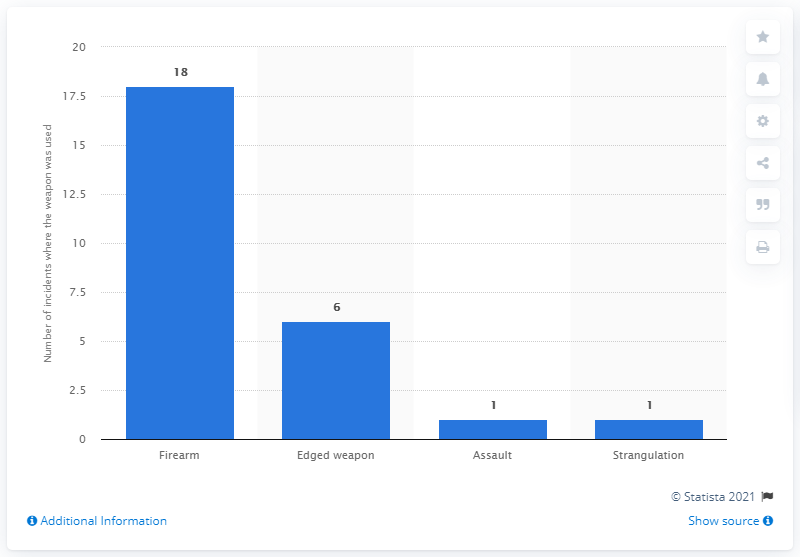Specify some key components in this picture. In the period between 2000 and 2016, firearms were used in 18 hate crime attacks. 